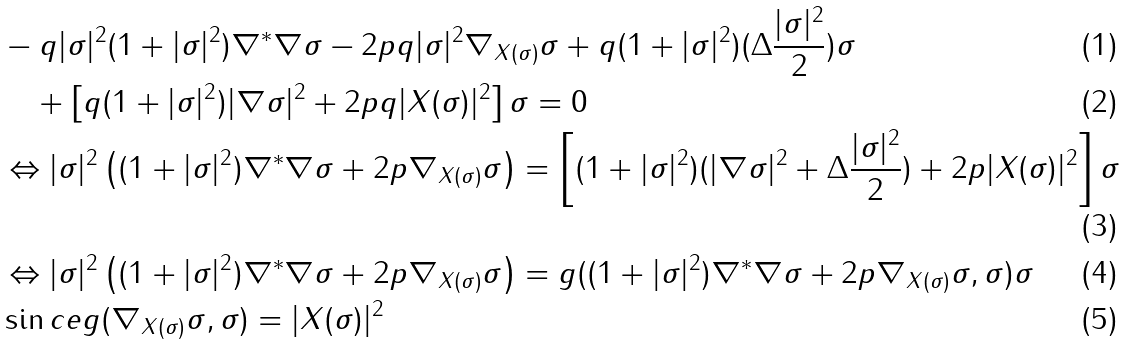<formula> <loc_0><loc_0><loc_500><loc_500>& - q | \sigma | ^ { 2 } ( 1 + | \sigma | ^ { 2 } ) \nabla ^ { * } \nabla \sigma - 2 p q | \sigma | ^ { 2 } \nabla _ { X ( \sigma ) } \sigma + q ( 1 + | \sigma | ^ { 2 } ) ( \Delta \frac { | \sigma | ^ { 2 } } { 2 } ) \sigma \\ & \quad + \left [ q ( 1 + | \sigma | ^ { 2 } ) | \nabla \sigma | ^ { 2 } + 2 p q | X ( \sigma ) | ^ { 2 } \right ] \sigma = 0 \\ & \Leftrightarrow | \sigma | ^ { 2 } \left ( ( 1 + | \sigma | ^ { 2 } ) \nabla ^ { * } \nabla \sigma + 2 p \nabla _ { X ( \sigma ) } \sigma \right ) = \left [ ( 1 + | \sigma | ^ { 2 } ) ( | \nabla \sigma | ^ { 2 } + \Delta \frac { | \sigma | ^ { 2 } } { 2 } ) + 2 p | X ( \sigma ) | ^ { 2 } \right ] \sigma \\ & \Leftrightarrow | \sigma | ^ { 2 } \left ( ( 1 + | \sigma | ^ { 2 } ) \nabla ^ { * } \nabla \sigma + 2 p \nabla _ { X ( \sigma ) } \sigma \right ) = g ( ( 1 + | \sigma | ^ { 2 } ) \nabla ^ { * } \nabla \sigma + 2 p \nabla _ { X ( \sigma ) } \sigma , \sigma ) \sigma \\ & \sin c e g ( \nabla _ { X ( \sigma ) } \sigma , \sigma ) = | X ( \sigma ) | ^ { 2 }</formula> 